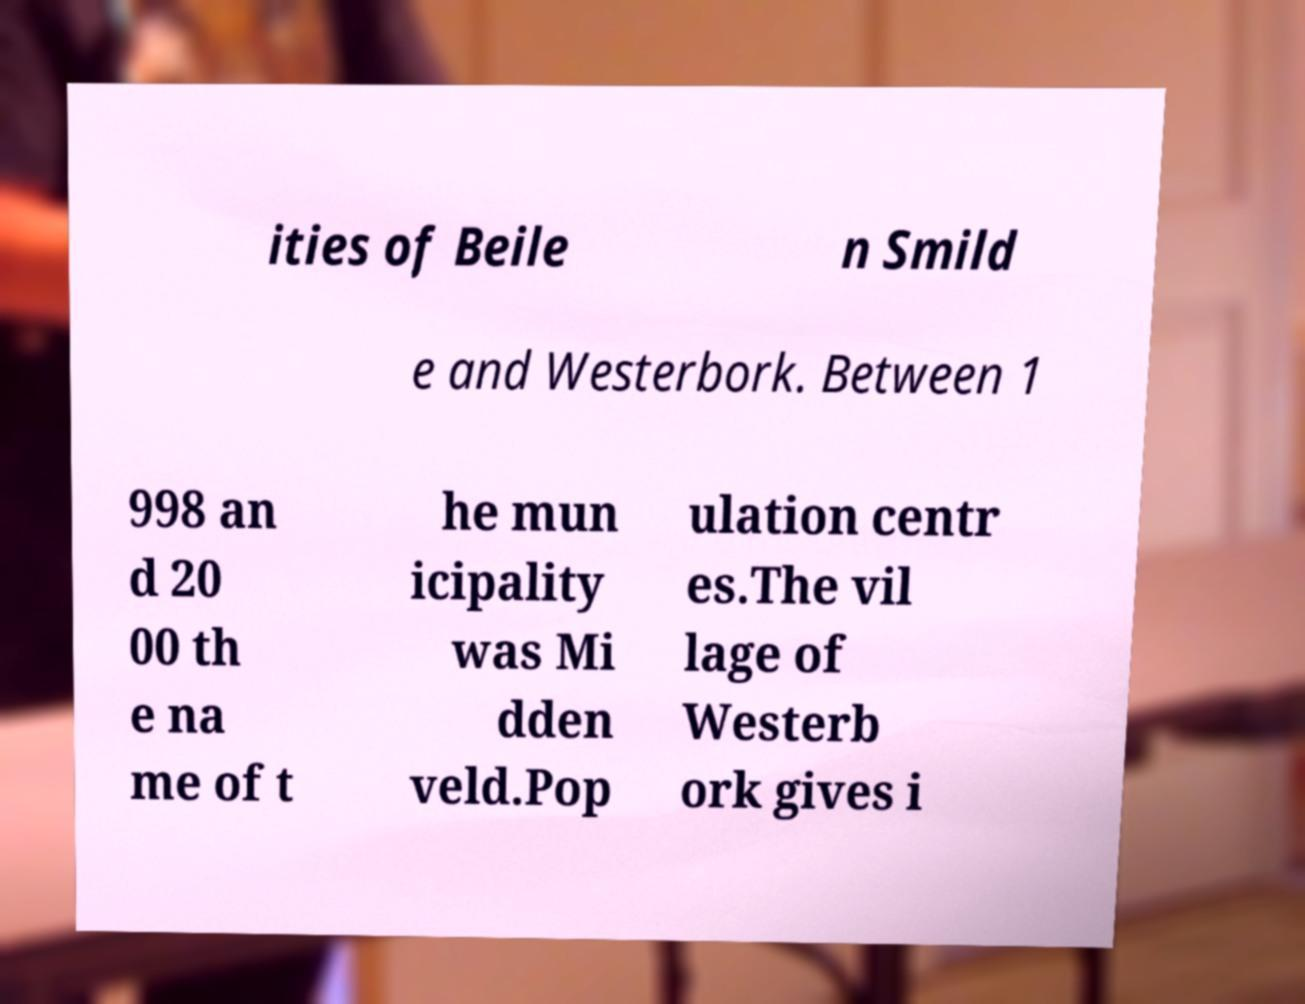Please read and relay the text visible in this image. What does it say? ities of Beile n Smild e and Westerbork. Between 1 998 an d 20 00 th e na me of t he mun icipality was Mi dden veld.Pop ulation centr es.The vil lage of Westerb ork gives i 